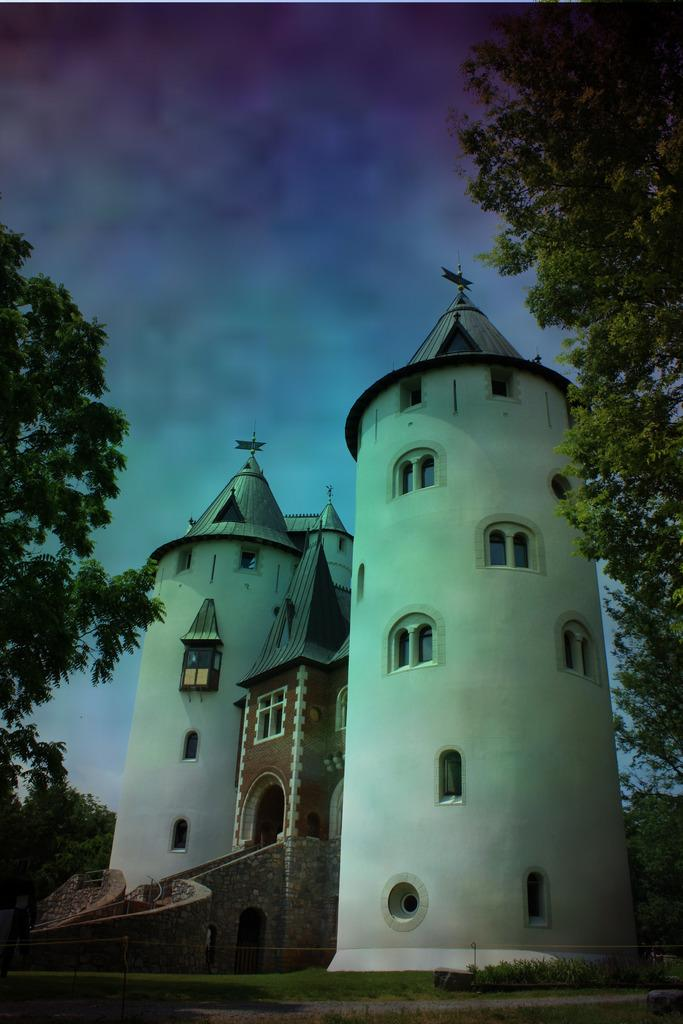What is the main subject of the picture? The main subject of the picture is a castle. What can be seen in the background of the picture? There are trees and a cloudy sky in the background of the picture. What type of scent can be smelled coming from the castle in the image? There is no indication of a scent in the image, as it is a visual representation of a castle and its surroundings. 